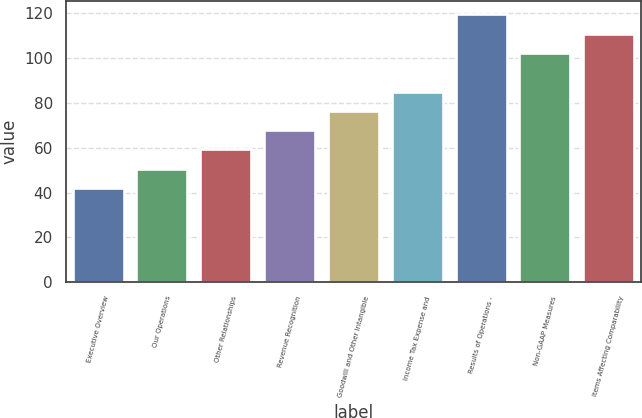Convert chart to OTSL. <chart><loc_0><loc_0><loc_500><loc_500><bar_chart><fcel>Executive Overview<fcel>Our Operations<fcel>Other Relationships<fcel>Revenue Recognition<fcel>Goodwill and Other Intangible<fcel>Income Tax Expense and<fcel>Results of Operations -<fcel>Non-GAAP Measures<fcel>Items Affecting Comparability<nl><fcel>42<fcel>50.6<fcel>59.2<fcel>67.8<fcel>76.4<fcel>85<fcel>119.4<fcel>102.2<fcel>110.8<nl></chart> 